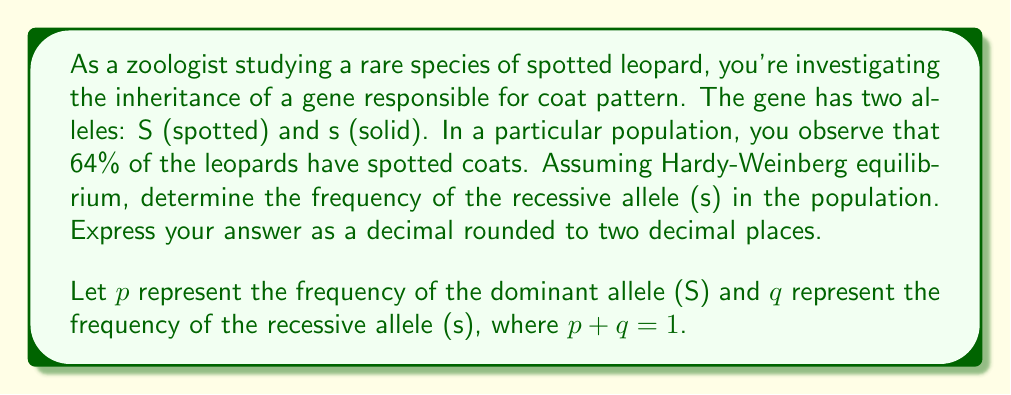Can you solve this math problem? To solve this problem, we'll use the Hardy-Weinberg principle and quadratic equations. Let's break it down step-by-step:

1) In Hardy-Weinberg equilibrium, the genotype frequencies are:
   $$SS = p^2, Ss = 2pq, ss = q^2$$

2) The spotted phenotype is expressed by genotypes SS and Ss. Therefore:
   $$p^2 + 2pq = 0.64$$

3) We know that $p + q = 1$, so $q = 1 - p$. Substituting this into our equation:
   $$p^2 + 2p(1-p) = 0.64$$

4) Expand the equation:
   $$p^2 + 2p - 2p^2 = 0.64$$

5) Simplify:
   $$-p^2 + 2p = 0.64$$

6) Rearrange to standard quadratic form:
   $$p^2 - 2p + 0.64 = 0$$

7) Use the quadratic formula: $p = \frac{-b \pm \sqrt{b^2 - 4ac}}{2a}$
   Where $a = 1$, $b = -2$, and $c = 0.64$

8) Solve:
   $$p = \frac{2 \pm \sqrt{4 - 2.56}}{2} = \frac{2 \pm \sqrt{1.44}}{2} = \frac{2 \pm 1.2}{2}$$

9) This gives us two solutions: $p = 1.6$ or $p = 0.4$

10) Since allele frequencies must be between 0 and 1, $p = 0.4$ is the only valid solution.

11) Remember, we're asked for the frequency of the recessive allele (q).
    Since $p + q = 1$, $q = 1 - p = 1 - 0.4 = 0.6$
Answer: $0.60$ 